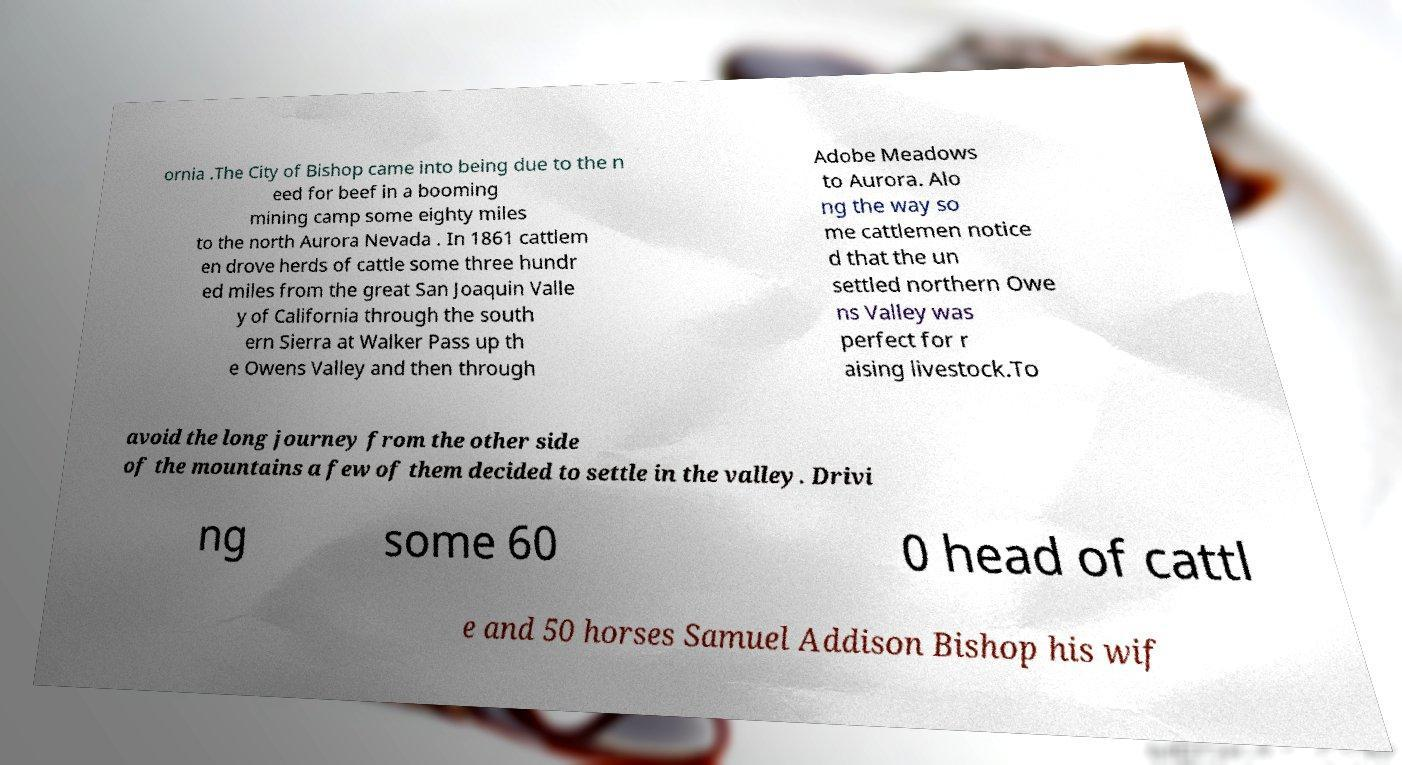Can you accurately transcribe the text from the provided image for me? ornia .The City of Bishop came into being due to the n eed for beef in a booming mining camp some eighty miles to the north Aurora Nevada . In 1861 cattlem en drove herds of cattle some three hundr ed miles from the great San Joaquin Valle y of California through the south ern Sierra at Walker Pass up th e Owens Valley and then through Adobe Meadows to Aurora. Alo ng the way so me cattlemen notice d that the un settled northern Owe ns Valley was perfect for r aising livestock.To avoid the long journey from the other side of the mountains a few of them decided to settle in the valley. Drivi ng some 60 0 head of cattl e and 50 horses Samuel Addison Bishop his wif 